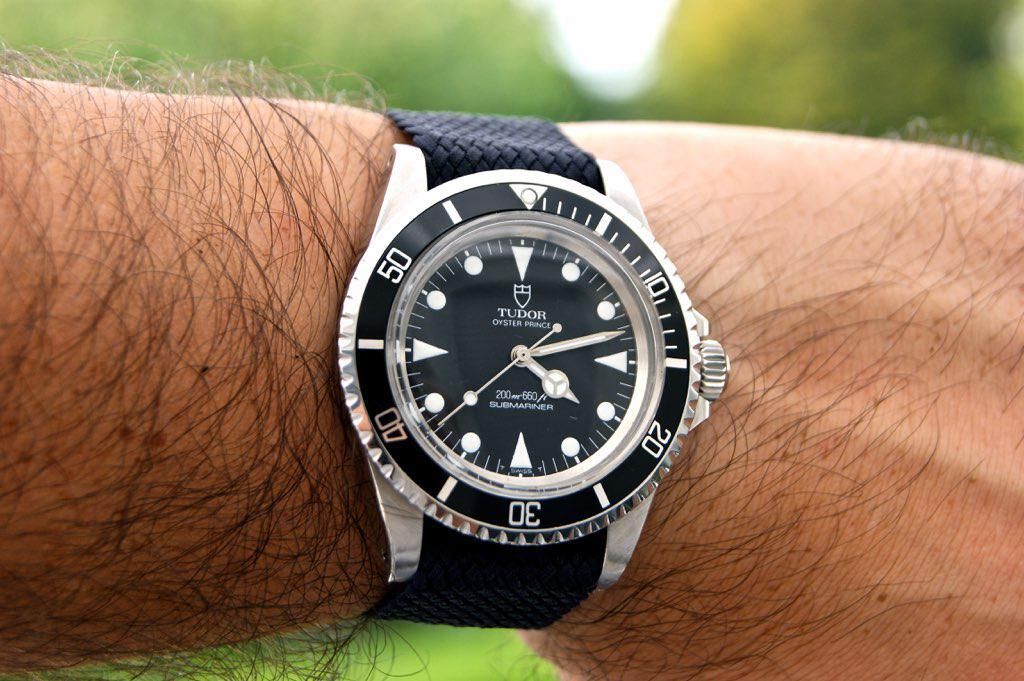<image>
Share a concise interpretation of the image provided. A Tudor watch has a black fabric band. 